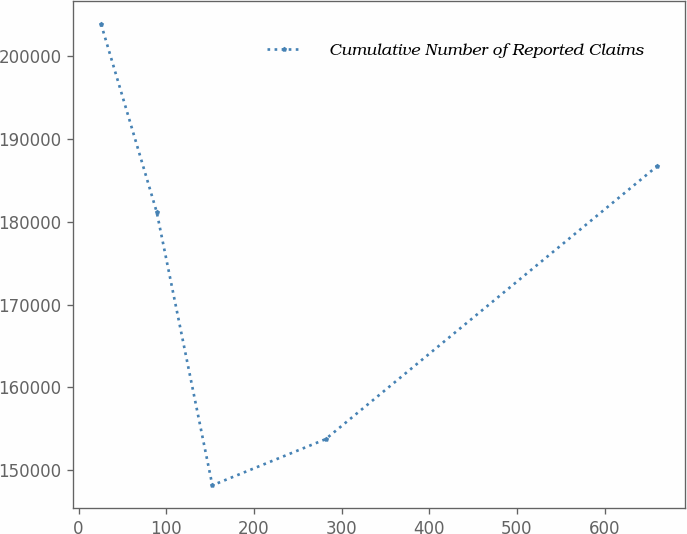Convert chart to OTSL. <chart><loc_0><loc_0><loc_500><loc_500><line_chart><ecel><fcel>Cumulative Number of Reported Claims<nl><fcel>25.75<fcel>203833<nl><fcel>89.21<fcel>181158<nl><fcel>152.67<fcel>148188<nl><fcel>281.8<fcel>153752<nl><fcel>660.32<fcel>186723<nl></chart> 